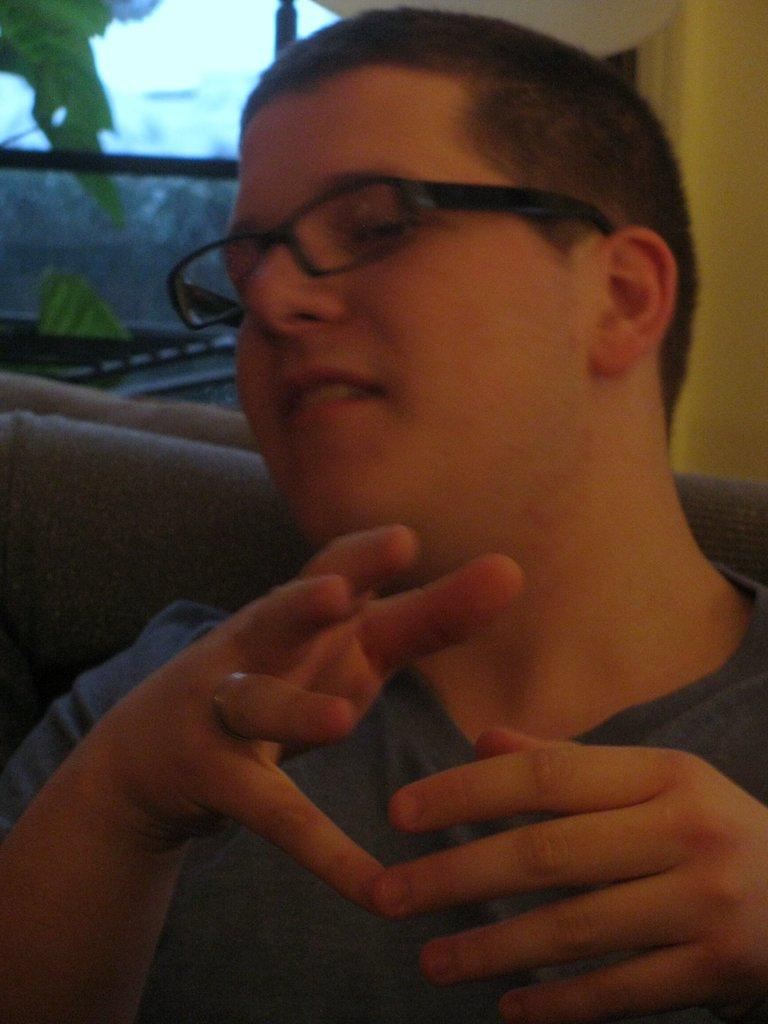Who is present in the image? There is a man in the image. What is the man wearing? The man is wearing spectacles. What can be seen through the window in the image? The facts do not specify what can be seen through the window. What color is present in the image? There are green color things in the image. What holiday is the man celebrating in the image? The facts do not mention any holiday, so we cannot determine if the man is celebrating a holiday in the image. Is the man's uncle present in the image? The facts do not mention any other person, so we cannot determine if the man's uncle is present in the image. 